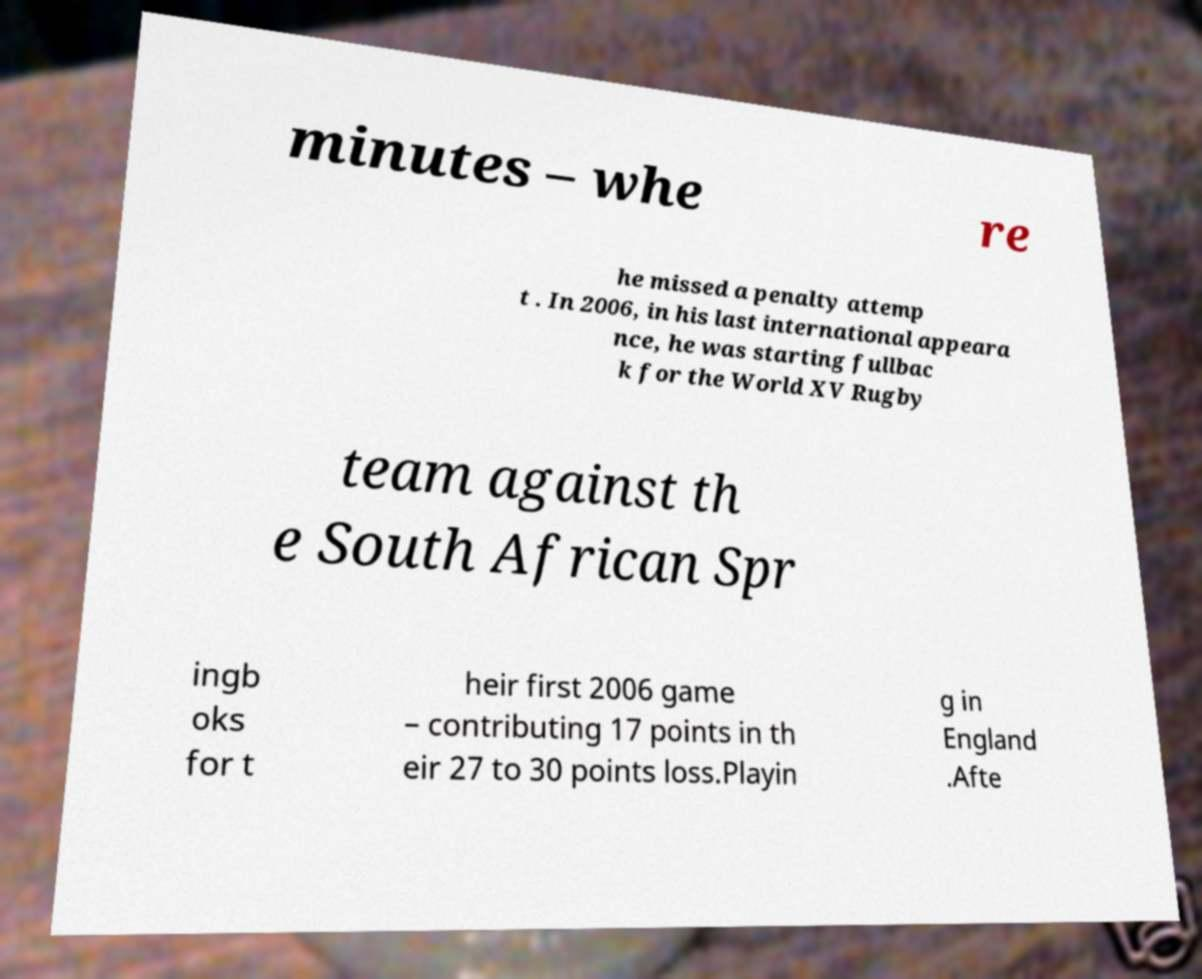Please identify and transcribe the text found in this image. minutes – whe re he missed a penalty attemp t . In 2006, in his last international appeara nce, he was starting fullbac k for the World XV Rugby team against th e South African Spr ingb oks for t heir first 2006 game – contributing 17 points in th eir 27 to 30 points loss.Playin g in England .Afte 